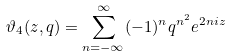<formula> <loc_0><loc_0><loc_500><loc_500>\vartheta _ { 4 } ( z , q ) = \sum ^ { \infty } _ { n = - \infty } ( - 1 ) ^ { n } q ^ { n ^ { 2 } } e ^ { 2 n i z }</formula> 